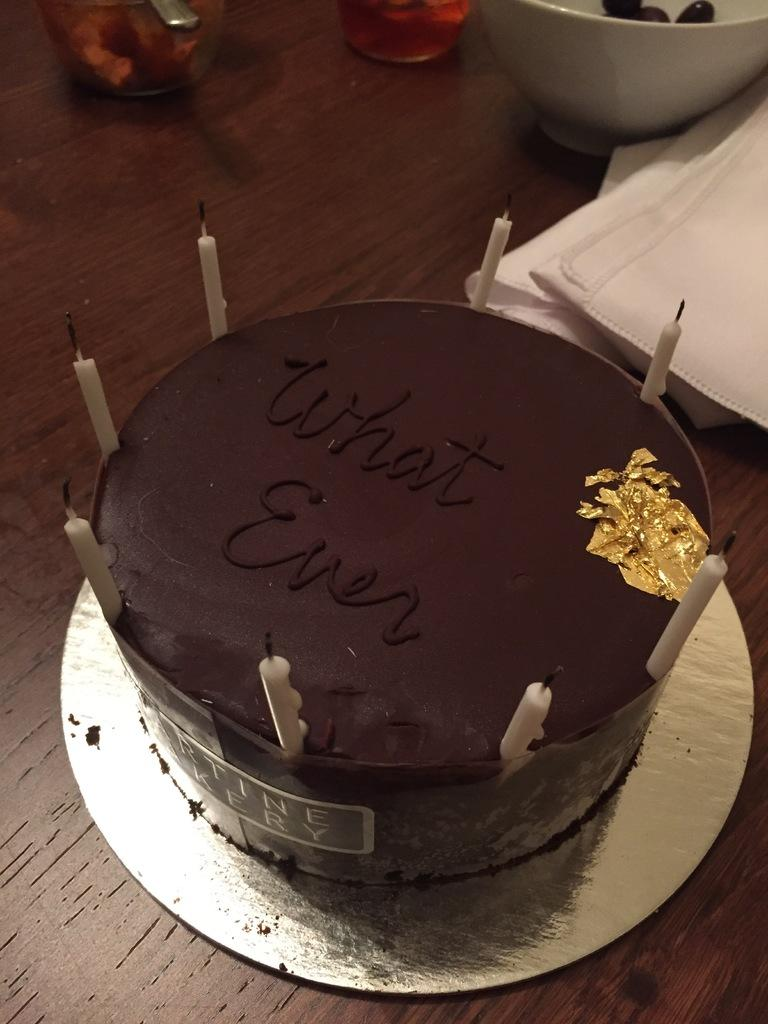What is the main subject of the image? There is a cake in the image. What is placed on top of the cake? There are candles on the cake. What message is written on the cake? The text "What Even" is written on the cake. What other object is visible in the image? There is a bowl in the image. What can be used for cleaning or wiping in the image? Tissues are present in the image. What type of organization is depicted on the cake? There is no organization depicted on the cake; it features the text "What Even." How many dolls are sitting on the tissues in the image? There are no dolls present in the image. 